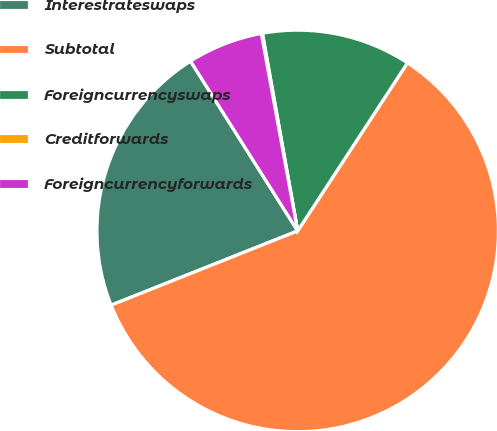Convert chart to OTSL. <chart><loc_0><loc_0><loc_500><loc_500><pie_chart><fcel>Interestrateswaps<fcel>Subtotal<fcel>Foreigncurrencyswaps<fcel>Creditforwards<fcel>Foreigncurrencyforwards<nl><fcel>22.07%<fcel>59.76%<fcel>12.02%<fcel>0.09%<fcel>6.06%<nl></chart> 